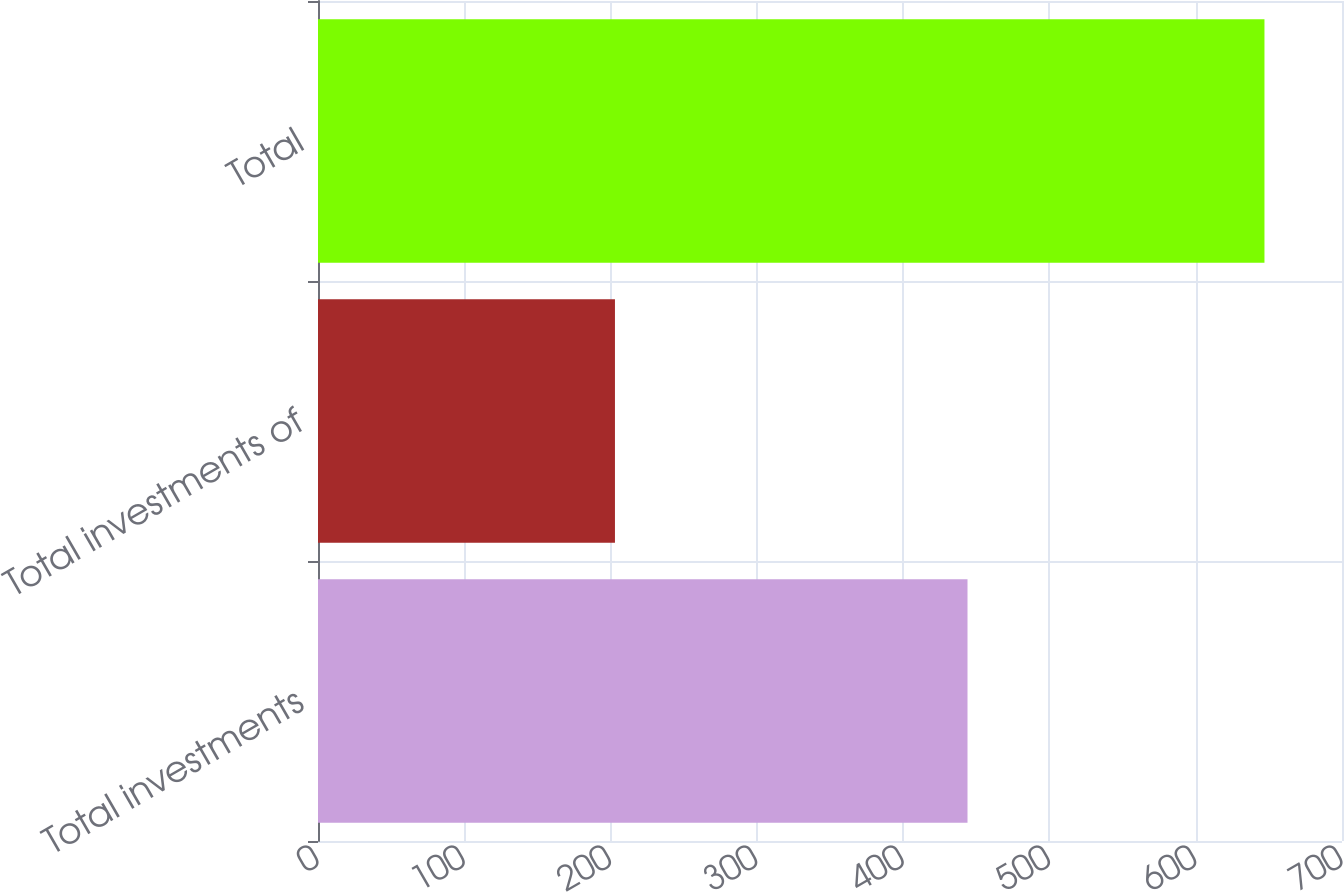<chart> <loc_0><loc_0><loc_500><loc_500><bar_chart><fcel>Total investments<fcel>Total investments of<fcel>Total<nl><fcel>444<fcel>203<fcel>647<nl></chart> 